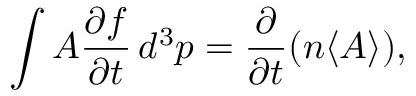<formula> <loc_0><loc_0><loc_500><loc_500>\int A { \frac { \partial f } { \partial t } } \, d ^ { 3 } p = { \frac { \partial } { \partial t } } ( n \langle A \rangle ) ,</formula> 